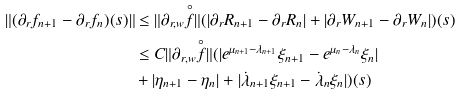Convert formula to latex. <formula><loc_0><loc_0><loc_500><loc_500>\| ( \partial _ { r } f _ { n + 1 } - \partial _ { r } f _ { n } ) ( s ) \| & \leq \| \partial _ { r , w } \overset { \circ } { f } \| ( | \partial _ { r } R _ { n + 1 } - \partial _ { r } R _ { n } | + | \partial _ { r } W _ { n + 1 } - \partial _ { r } W _ { n } | ) ( s ) \\ & \leq C \| \partial _ { r , w } \overset { \circ } { f } \| ( | e ^ { \mu _ { n + 1 } - \lambda _ { n + 1 } } \xi _ { n + 1 } - e ^ { \mu _ { n } - \lambda _ { n } } \xi _ { n } | \\ & + | \eta _ { n + 1 } - \eta _ { n } | + | \dot { \lambda } _ { n + 1 } \xi _ { n + 1 } - \dot { \lambda } _ { n } \xi _ { n } | ) ( s )</formula> 